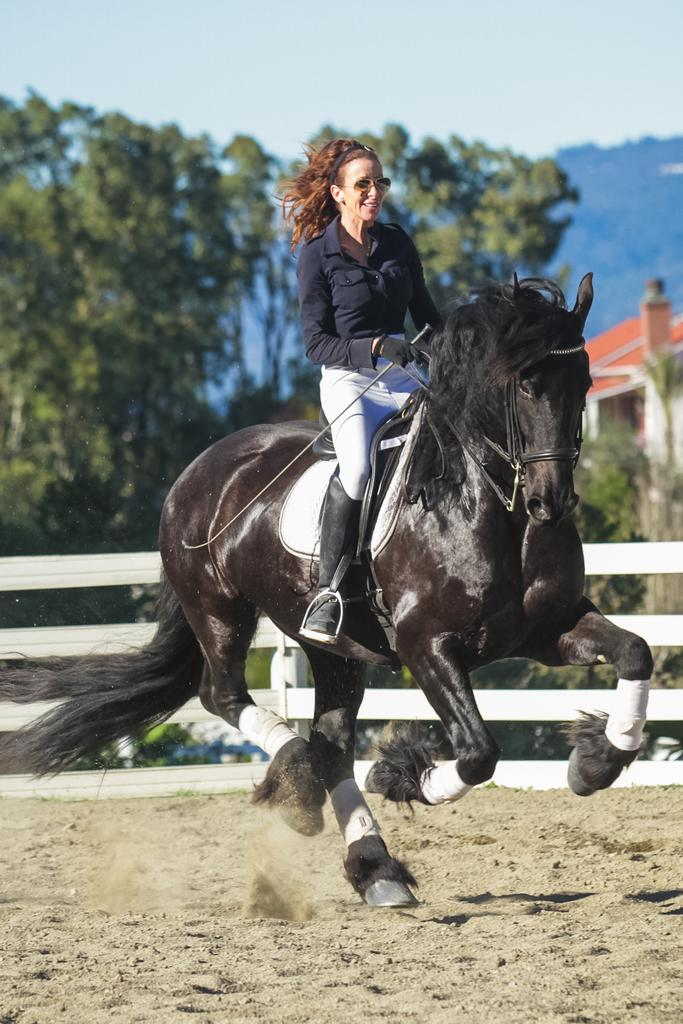Who is the main subject in the image? There is a woman in the image. What is the woman doing in the image? The woman is riding a horse. What can be seen behind the horse in the image? There is a wooden fence behind the horse. What type of natural environment is visible in the background of the image? There are trees in the background of the image. What type of structure can be seen in the background of the image? There is a building in the background of the image. What is visible in the sky in the image? The sky is visible in the background of the image. What type of metal is the woman using to ride the horse in the image? There is no mention of any metal being used in the image. The woman is riding a horse, and there is a wooden fence behind the horse. The image also shows trees, a building, and the sky in the background. 